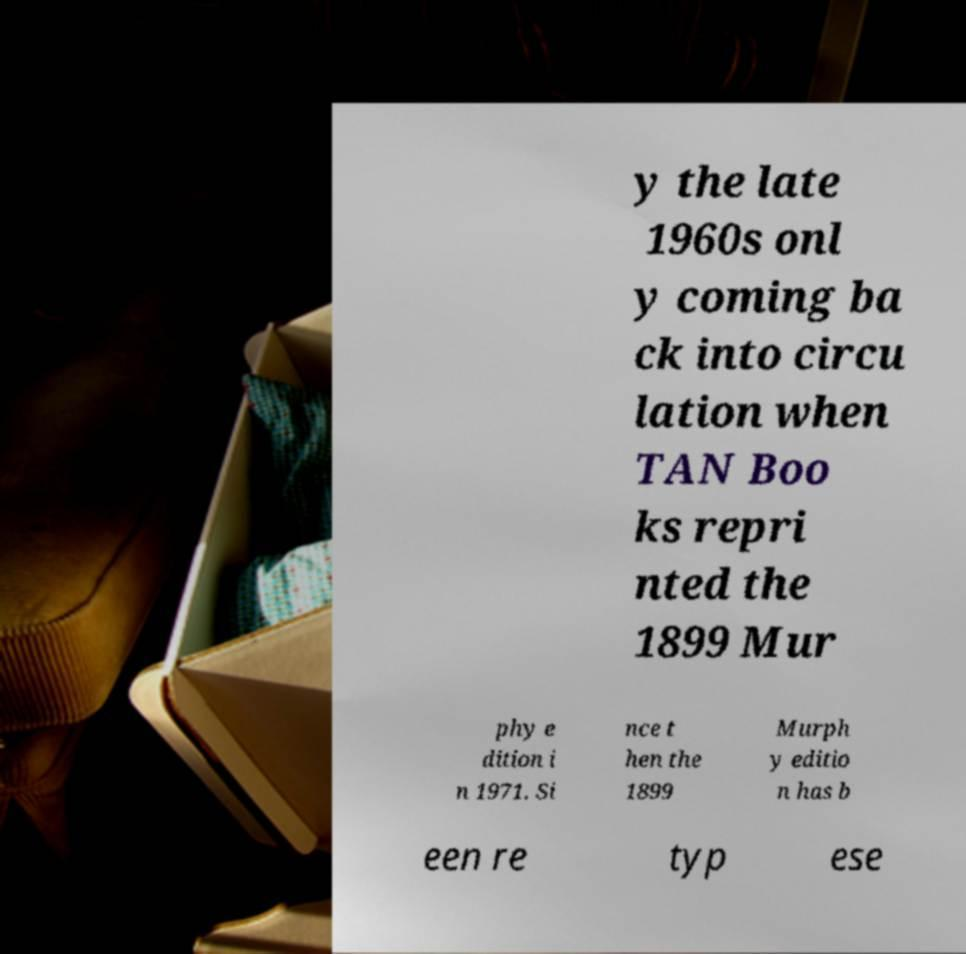There's text embedded in this image that I need extracted. Can you transcribe it verbatim? y the late 1960s onl y coming ba ck into circu lation when TAN Boo ks repri nted the 1899 Mur phy e dition i n 1971. Si nce t hen the 1899 Murph y editio n has b een re typ ese 